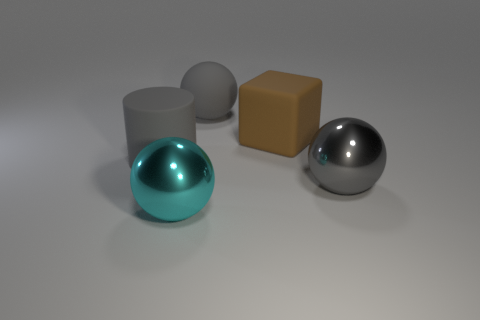Add 1 large metallic objects. How many objects exist? 6 Subtract all gray spheres. How many spheres are left? 1 Subtract all gray balls. How many balls are left? 1 Subtract all cubes. How many objects are left? 4 Add 4 small cyan metallic cylinders. How many small cyan metallic cylinders exist? 4 Subtract 0 yellow cylinders. How many objects are left? 5 Subtract 1 cylinders. How many cylinders are left? 0 Subtract all purple cylinders. Subtract all yellow balls. How many cylinders are left? 1 Subtract all green cylinders. How many blue balls are left? 0 Subtract all brown rubber cubes. Subtract all rubber cubes. How many objects are left? 3 